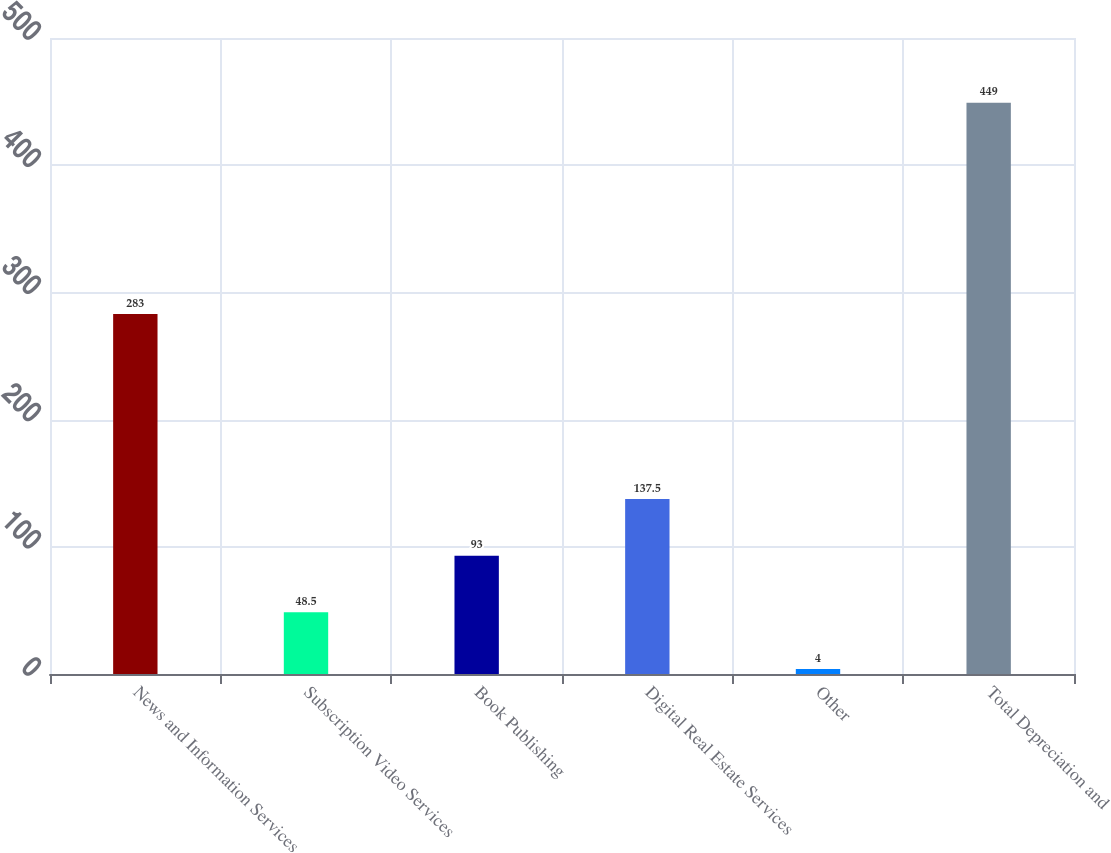<chart> <loc_0><loc_0><loc_500><loc_500><bar_chart><fcel>News and Information Services<fcel>Subscription Video Services<fcel>Book Publishing<fcel>Digital Real Estate Services<fcel>Other<fcel>Total Depreciation and<nl><fcel>283<fcel>48.5<fcel>93<fcel>137.5<fcel>4<fcel>449<nl></chart> 